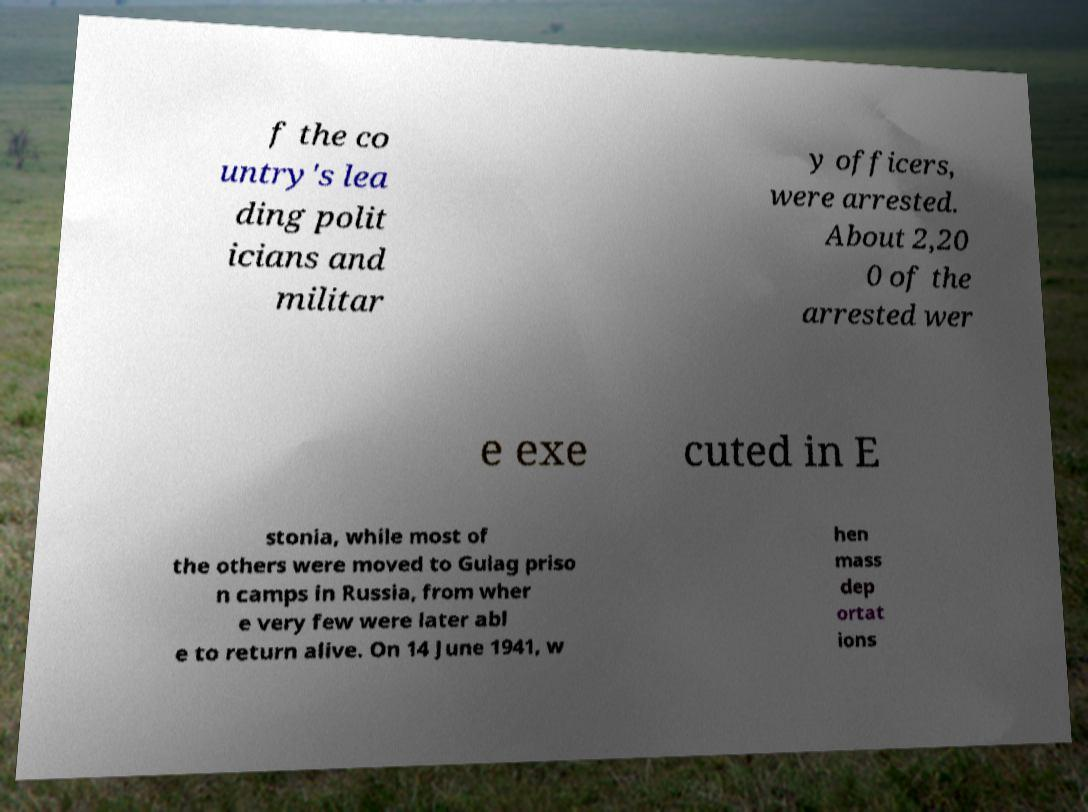Could you assist in decoding the text presented in this image and type it out clearly? f the co untry's lea ding polit icians and militar y officers, were arrested. About 2,20 0 of the arrested wer e exe cuted in E stonia, while most of the others were moved to Gulag priso n camps in Russia, from wher e very few were later abl e to return alive. On 14 June 1941, w hen mass dep ortat ions 